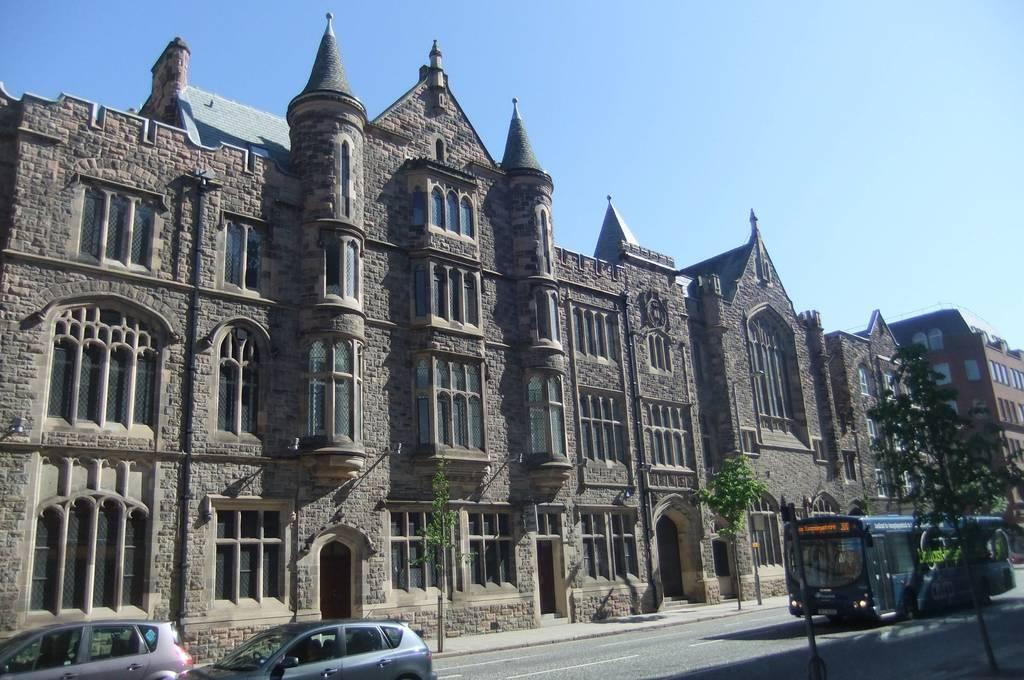What types of vehicles can be seen on the road in the image? There are buses and cars on the road in the image. What type of natural vegetation is visible in the image? There are trees visible in the image. What type of man-made structures are visible in the image? There are buildings visible in the image. What part of the buildings can be seen in the image? There are windows visible in the image. What is visible at the top of the image? The sky is visible in the image. What type of leather cap is the uncle wearing in the image? There is no uncle or leather cap present in the image. What type of leather material is visible in the image? There is no leather material visible in the image. 